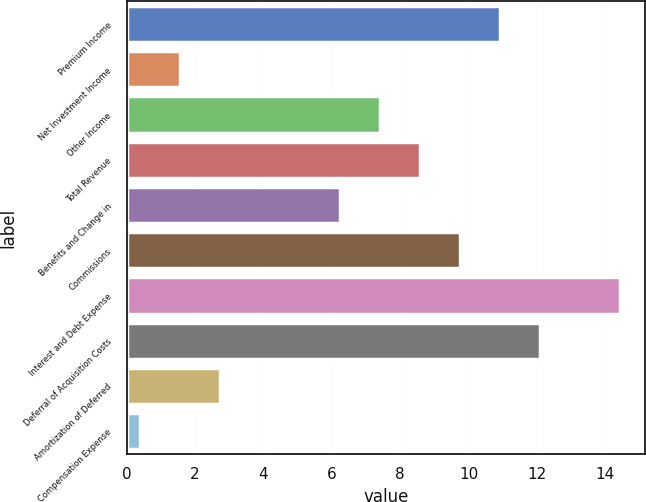Convert chart. <chart><loc_0><loc_0><loc_500><loc_500><bar_chart><fcel>Premium Income<fcel>Net Investment Income<fcel>Other Income<fcel>Total Revenue<fcel>Benefits and Change in<fcel>Commissions<fcel>Interest and Debt Expense<fcel>Deferral of Acquisition Costs<fcel>Amortization of Deferred<fcel>Compensation Expense<nl><fcel>10.93<fcel>1.57<fcel>7.42<fcel>8.59<fcel>6.25<fcel>9.76<fcel>14.44<fcel>12.1<fcel>2.74<fcel>0.4<nl></chart> 